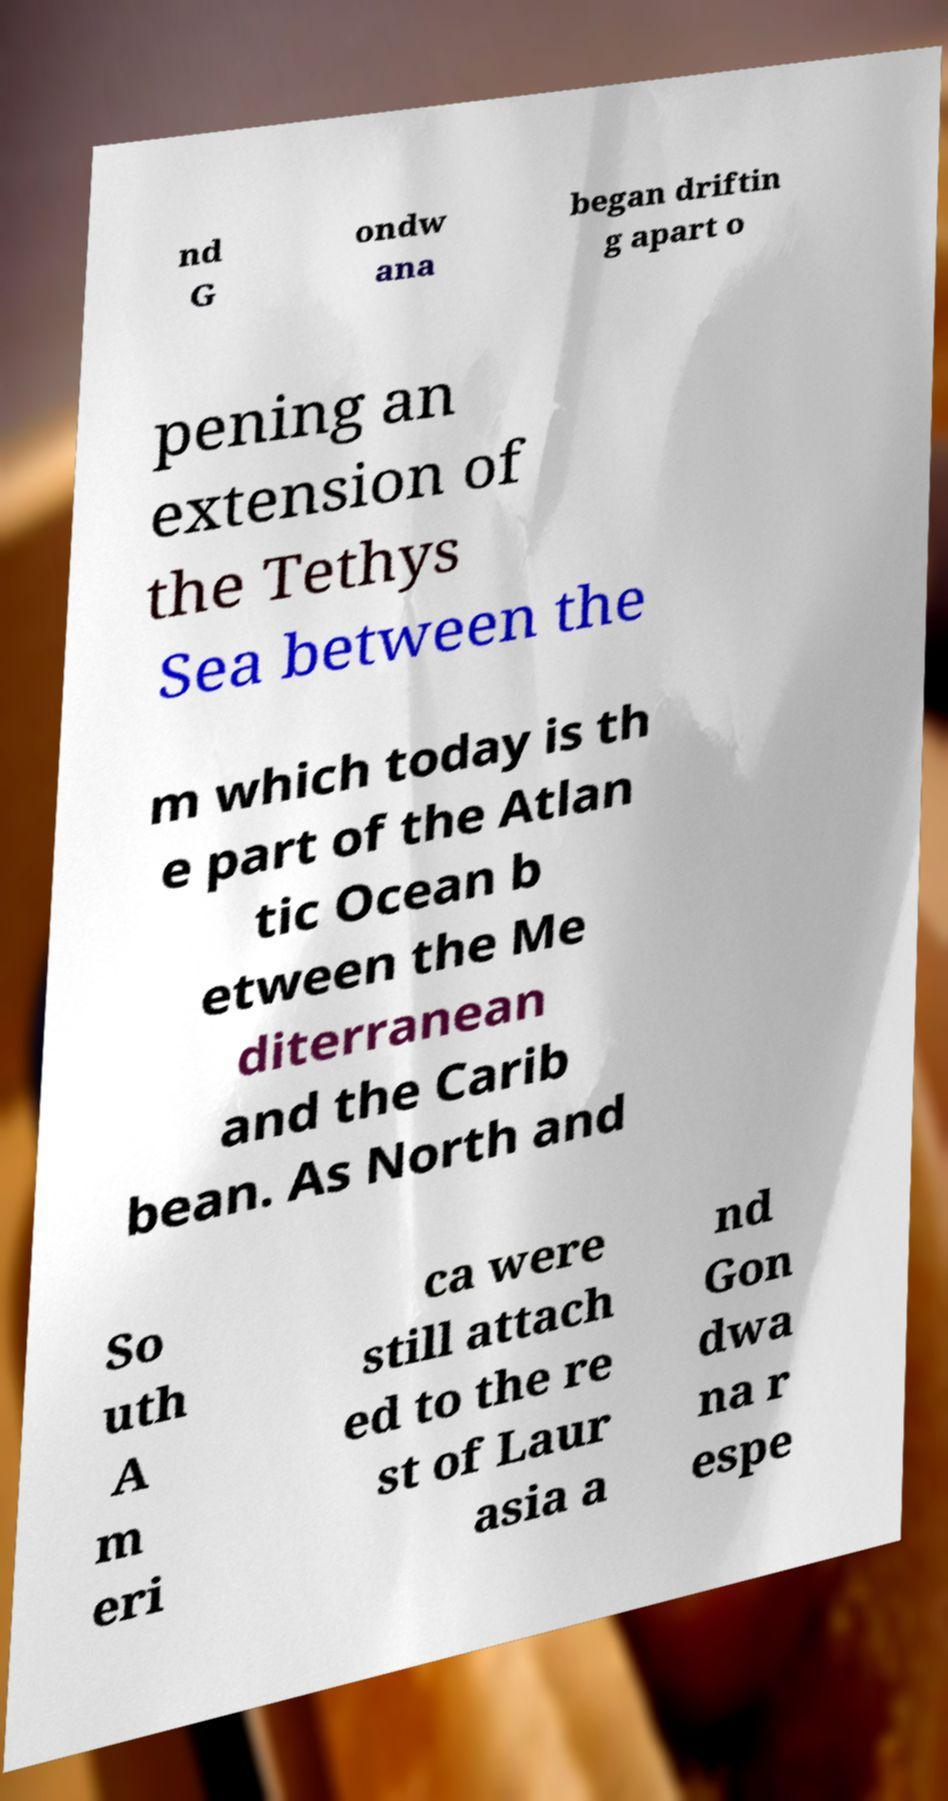Please read and relay the text visible in this image. What does it say? nd G ondw ana began driftin g apart o pening an extension of the Tethys Sea between the m which today is th e part of the Atlan tic Ocean b etween the Me diterranean and the Carib bean. As North and So uth A m eri ca were still attach ed to the re st of Laur asia a nd Gon dwa na r espe 